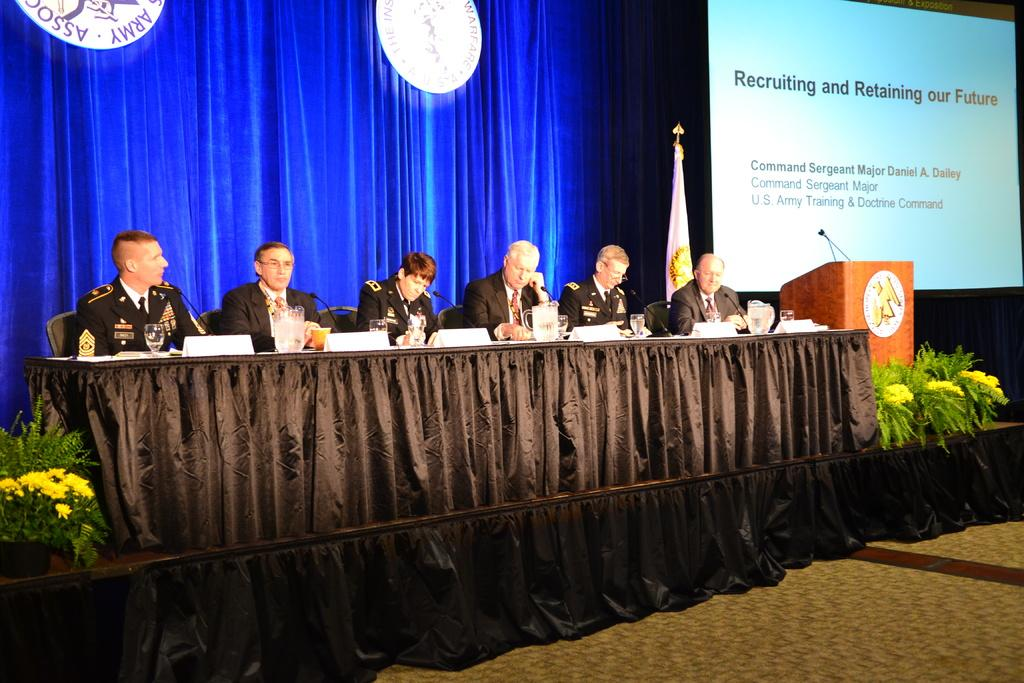What is the main subject of the image? The main subject of the image is a group of men. What are the men doing in the image? The men are sitting on chairs in the image. What type of clothing are the men wearing? The men are wearing coats, ties, and shirts in the image. What can be seen in the background of the image? There is a blue color curtain in the background of the image. What objects are on the right side of the image? There is a podium and a projector screen on the right side of the image. What type of vacation destination can be seen in the image? There is no vacation destination present in the image; it features a group of men sitting in chairs. What type of teeth can be seen in the image? There are no teeth visible in the image, as it features a group of men sitting in chairs and wearing coats, ties, and shirts. 